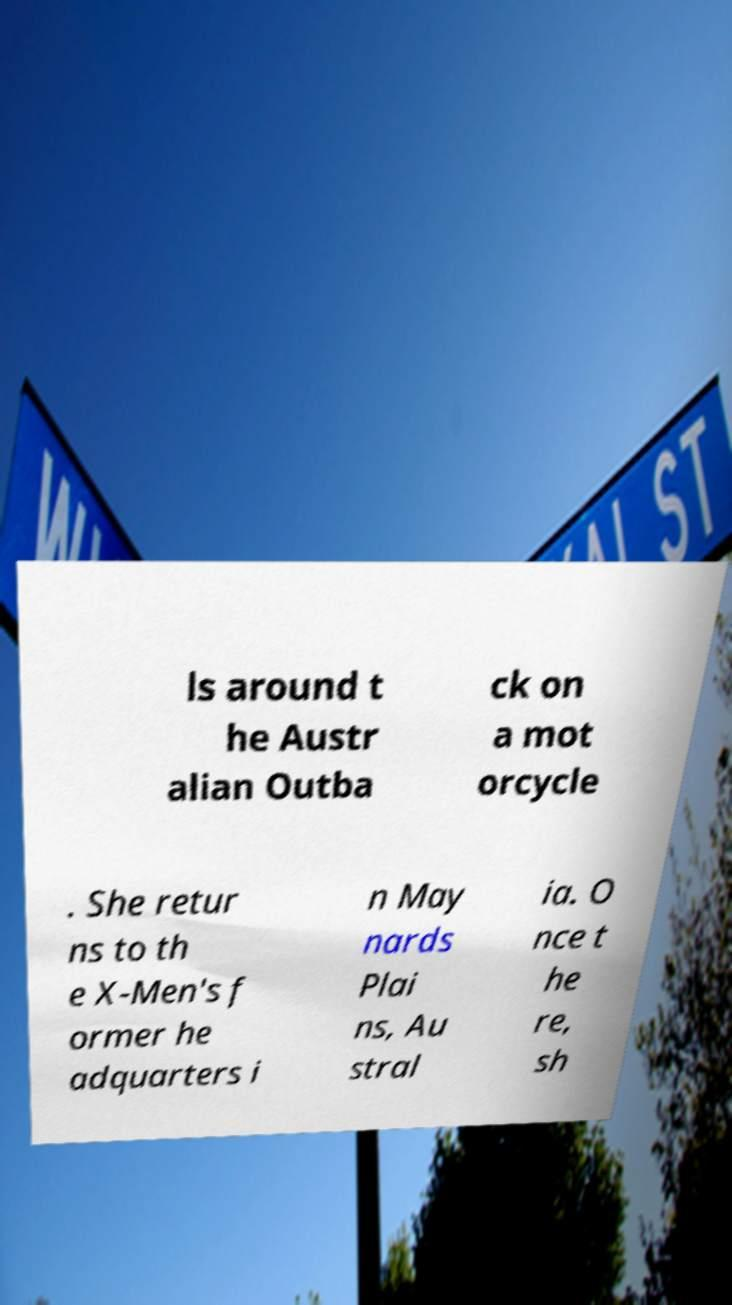There's text embedded in this image that I need extracted. Can you transcribe it verbatim? ls around t he Austr alian Outba ck on a mot orcycle . She retur ns to th e X-Men's f ormer he adquarters i n May nards Plai ns, Au stral ia. O nce t he re, sh 